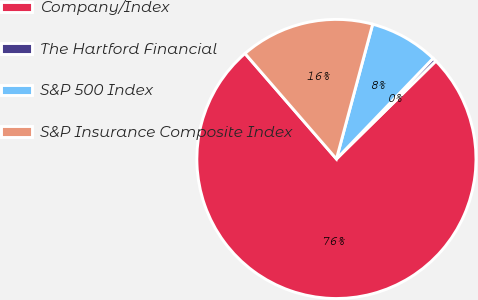Convert chart. <chart><loc_0><loc_0><loc_500><loc_500><pie_chart><fcel>Company/Index<fcel>The Hartford Financial<fcel>S&P 500 Index<fcel>S&P Insurance Composite Index<nl><fcel>76.0%<fcel>0.44%<fcel>8.0%<fcel>15.55%<nl></chart> 